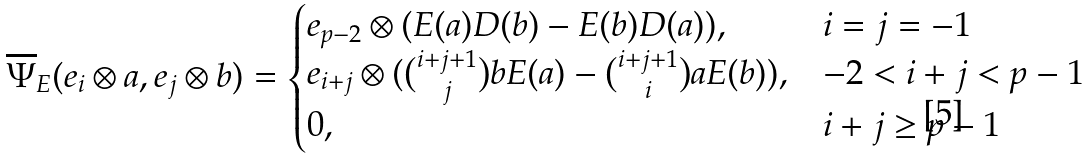<formula> <loc_0><loc_0><loc_500><loc_500>\overline { \Psi } _ { E } ( e _ { i } \otimes a , e _ { j } \otimes b ) = \begin{cases} e _ { p - 2 } \otimes ( E ( a ) D ( b ) - E ( b ) D ( a ) ) , & i = j = - 1 \\ e _ { i + j } \otimes ( \binom { i + j + 1 } j b E ( a ) - \binom { i + j + 1 } i a E ( b ) ) , & - 2 < i + j < p - 1 \\ 0 , & i + j \geq p - 1 \end{cases}</formula> 